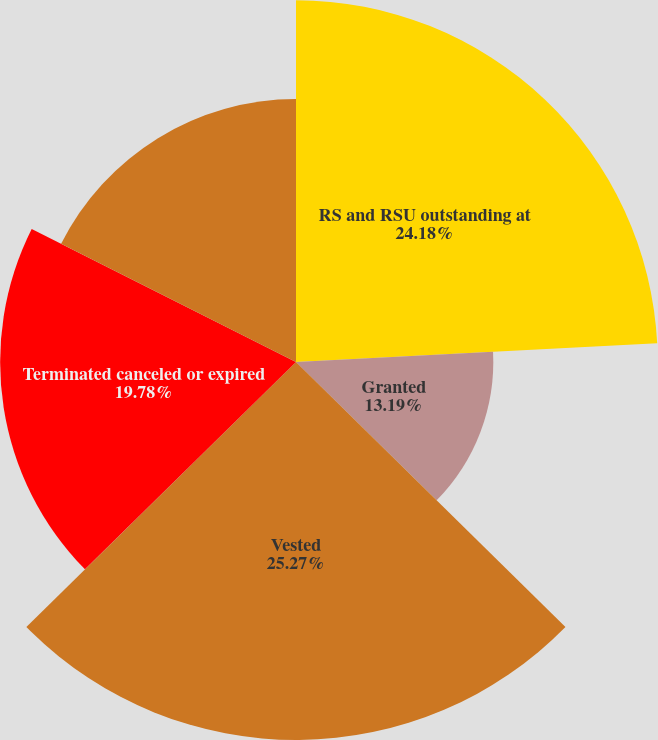Convert chart. <chart><loc_0><loc_0><loc_500><loc_500><pie_chart><fcel>RS and RSU outstanding at<fcel>Granted<fcel>Vested<fcel>Terminated canceled or expired<fcel>RSU outstanding at December 31<nl><fcel>24.18%<fcel>13.19%<fcel>25.27%<fcel>19.78%<fcel>17.58%<nl></chart> 